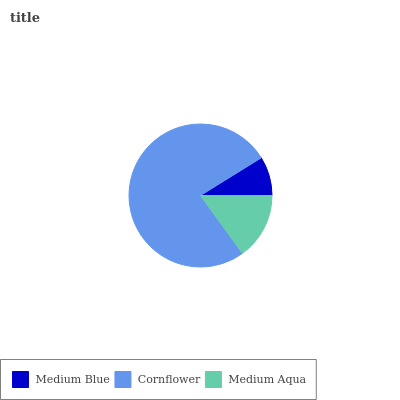Is Medium Blue the minimum?
Answer yes or no. Yes. Is Cornflower the maximum?
Answer yes or no. Yes. Is Medium Aqua the minimum?
Answer yes or no. No. Is Medium Aqua the maximum?
Answer yes or no. No. Is Cornflower greater than Medium Aqua?
Answer yes or no. Yes. Is Medium Aqua less than Cornflower?
Answer yes or no. Yes. Is Medium Aqua greater than Cornflower?
Answer yes or no. No. Is Cornflower less than Medium Aqua?
Answer yes or no. No. Is Medium Aqua the high median?
Answer yes or no. Yes. Is Medium Aqua the low median?
Answer yes or no. Yes. Is Cornflower the high median?
Answer yes or no. No. Is Medium Blue the low median?
Answer yes or no. No. 